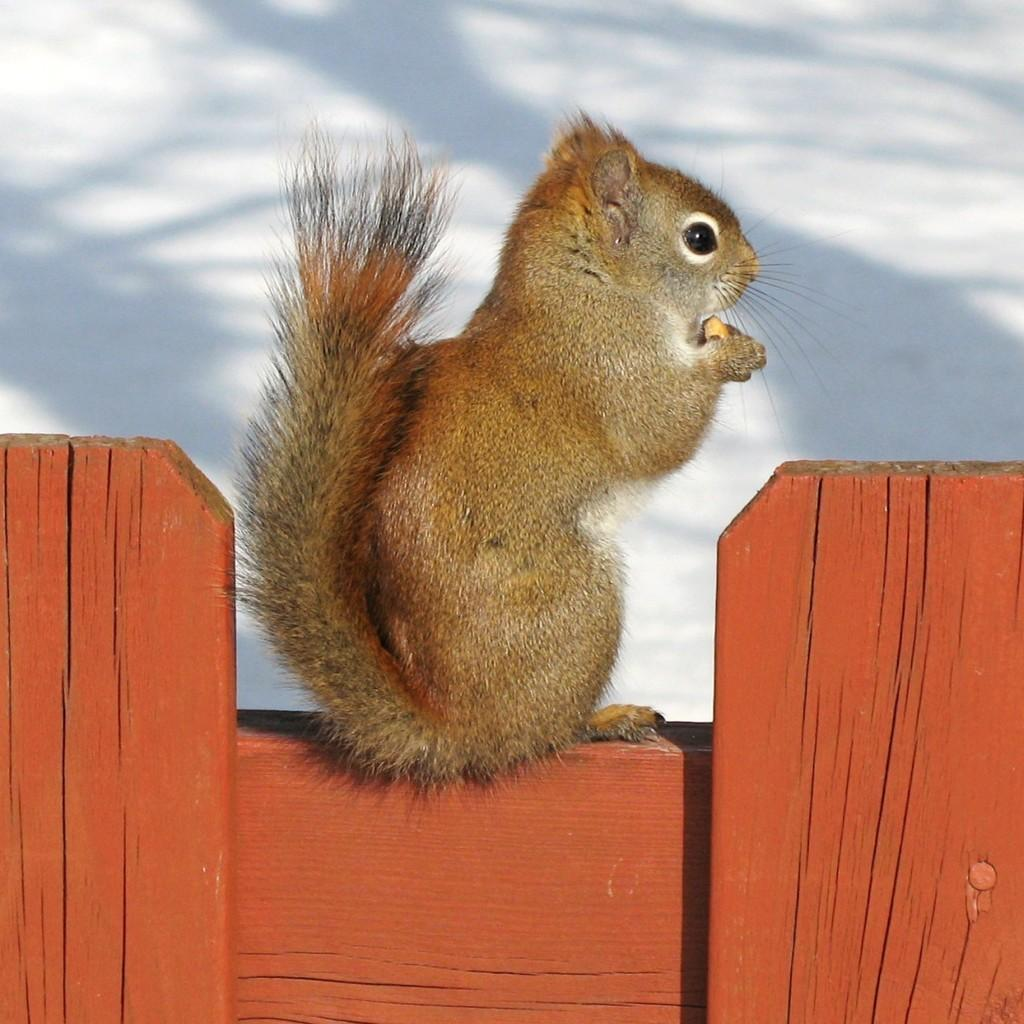What is the main feature of the image? There is a wall in the image. What color is the wall? The wall is red in color. Are there any animals on the wall? Yes, there is a squirrel on the wall. What can be seen in the background of the image? The sky is visible in the background of the image. What type of winter trade is depicted in the image? There is no depiction of winter trade in the image; it features a red wall with a squirrel on it and a visible sky in the background. 